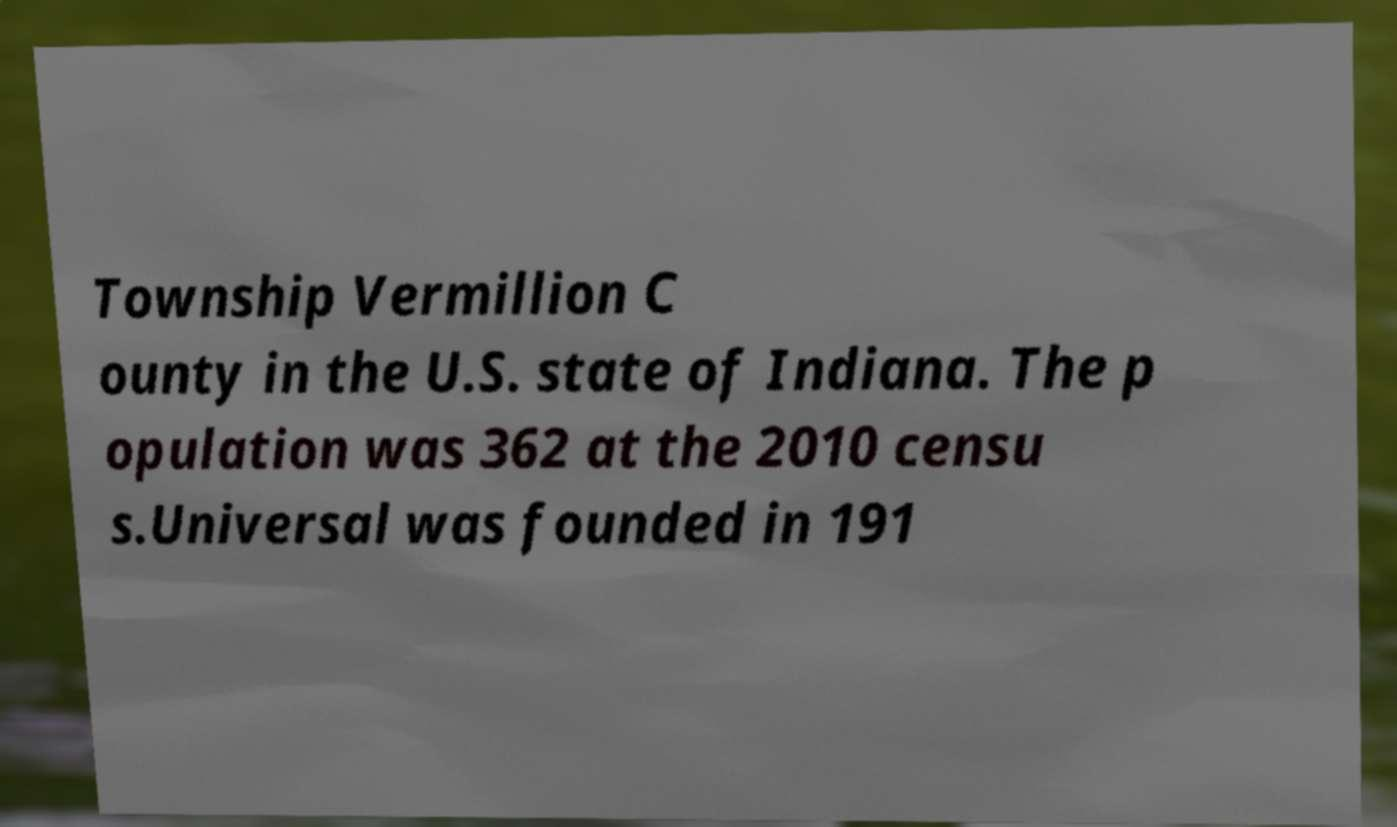There's text embedded in this image that I need extracted. Can you transcribe it verbatim? Township Vermillion C ounty in the U.S. state of Indiana. The p opulation was 362 at the 2010 censu s.Universal was founded in 191 